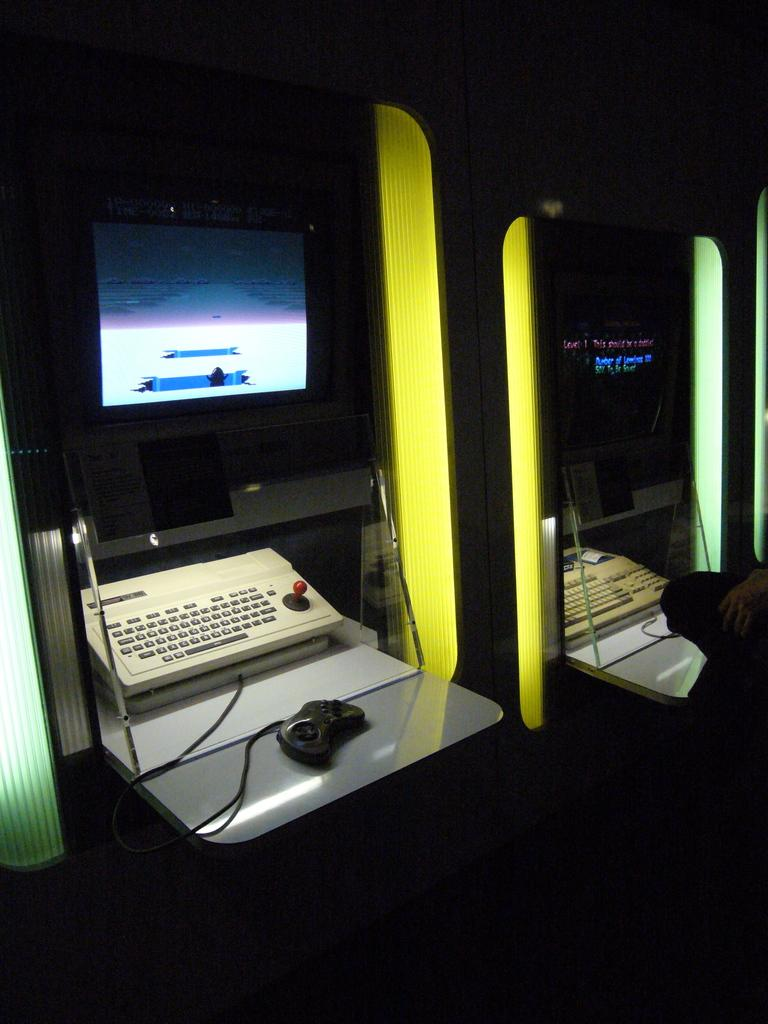What type of electronic devices are present in the image? There are monitors in the image. What type of controller is visible in the image? There is a joystick in the image. What connects the devices in the image? There are wires visible in the image. What is the size of the ship in the image? There is no ship present in the image. What is the temper of the monitors in the image? Monitors do not have a temper; they are electronic devices that display images. 